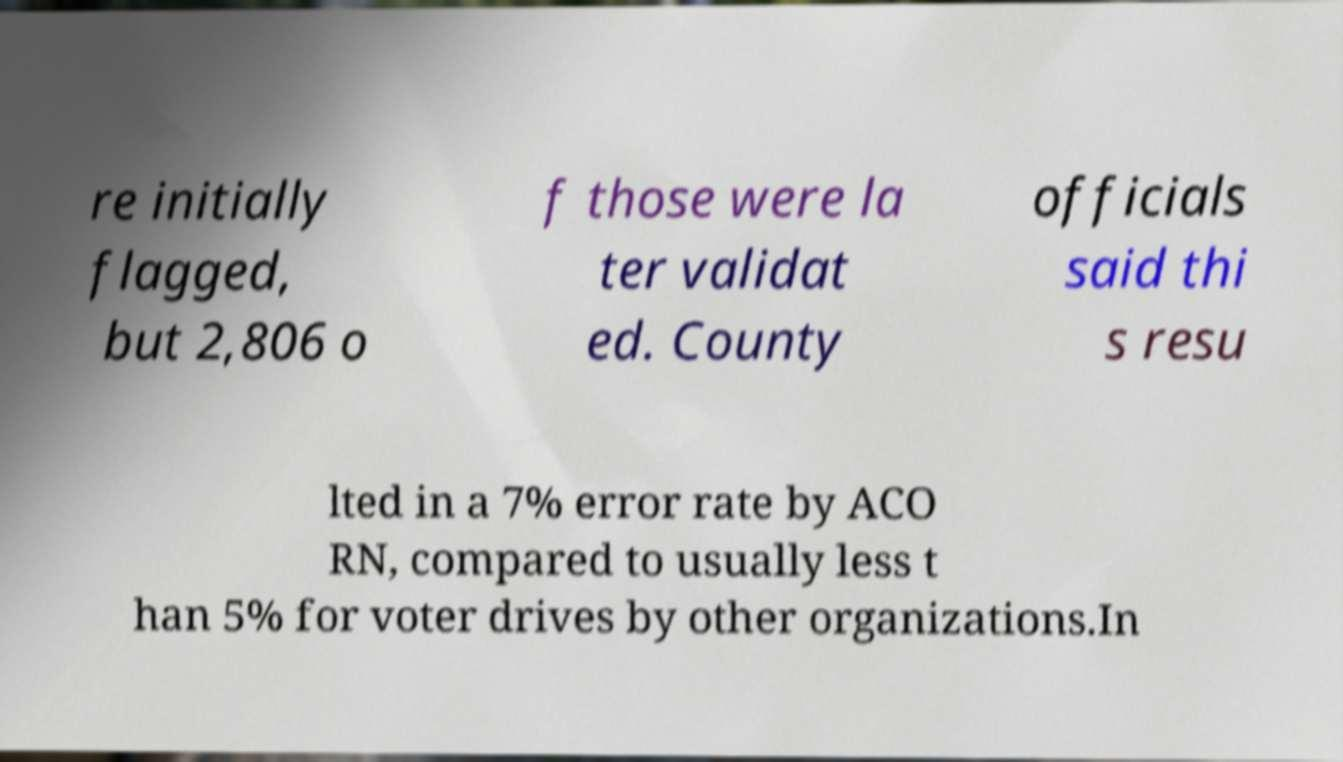Could you assist in decoding the text presented in this image and type it out clearly? re initially flagged, but 2,806 o f those were la ter validat ed. County officials said thi s resu lted in a 7% error rate by ACO RN, compared to usually less t han 5% for voter drives by other organizations.In 